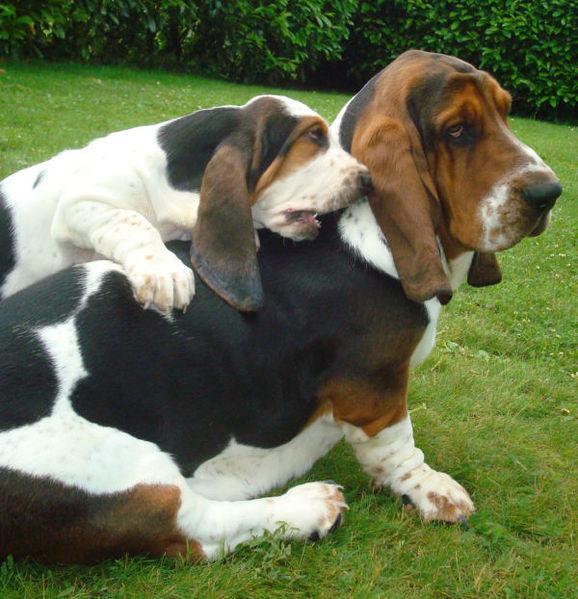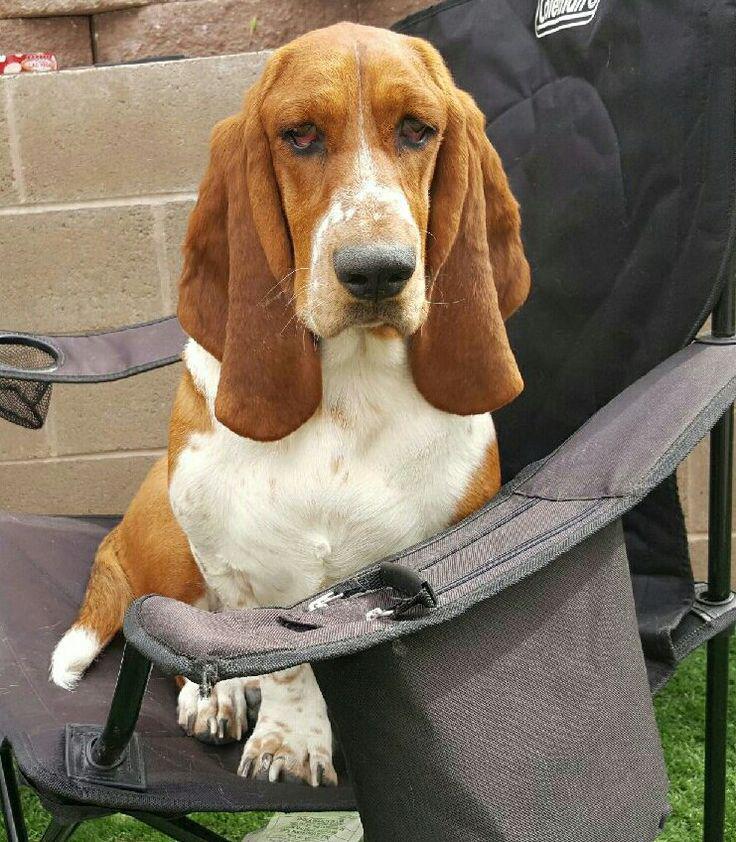The first image is the image on the left, the second image is the image on the right. Analyze the images presented: Is the assertion "The dog in the image on the left is sitting on grass." valid? Answer yes or no. Yes. The first image is the image on the left, the second image is the image on the right. Given the left and right images, does the statement "One image shows a basset hound sitting on furniture made for humans." hold true? Answer yes or no. Yes. 